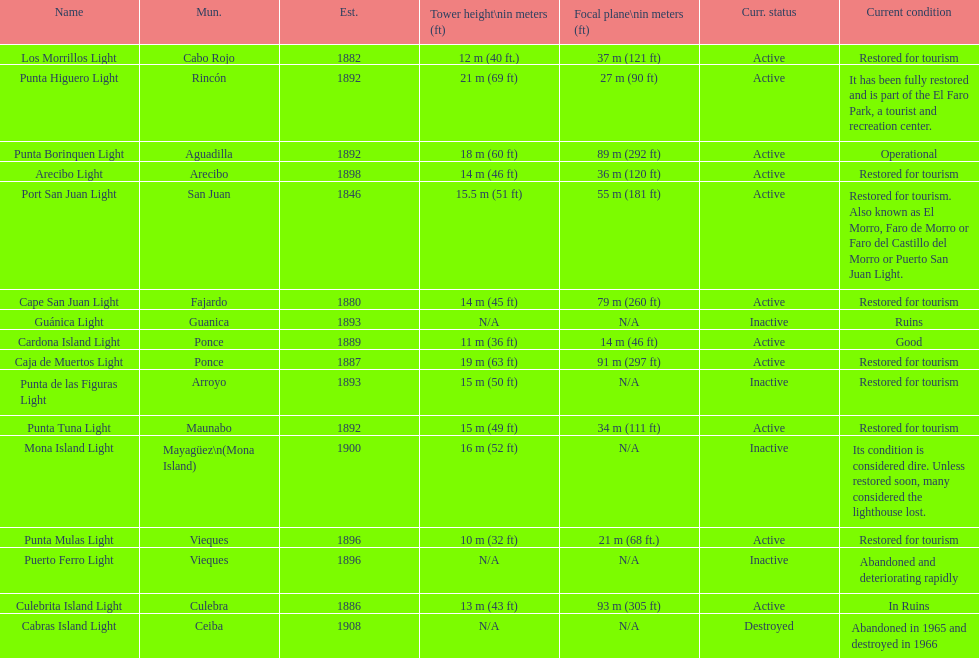Number of lighthouses that begin with the letter p 7. 